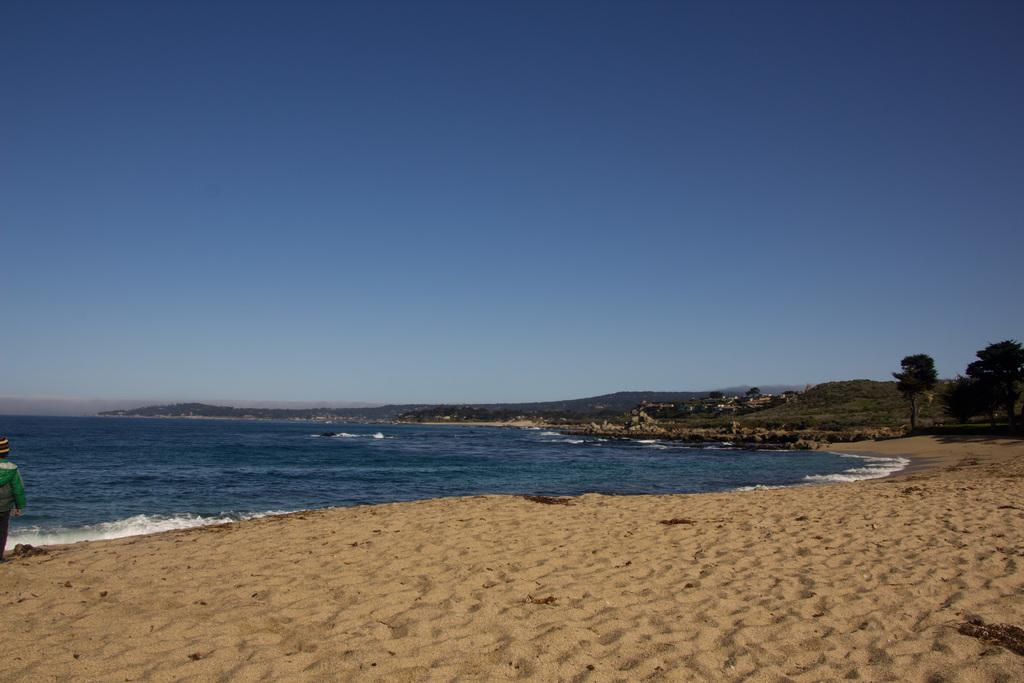What is the person in the image doing? The person is standing on the seashore. What is the main feature of the image? There is a large water body in the image. What type of vegetation can be seen in the image? There are trees visible in the image. What type of landscape is present in the image? The hills are present in the image. What is the weather like in the image? The sky is cloudy in the image. What type of paper is the person holding in the image? There is no paper present in the image; the person is standing on the seashore. 